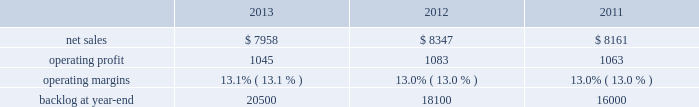Frequency ( aehf ) system , orion , global positioning satellite ( gps ) iii system , geostationary operational environmental satellite r-series ( goes-r ) , and mobile user objective system ( muos ) .
Operating profit for our space systems business segment includes our share of earnings for our investment in united launch alliance ( ula ) , which provides expendable launch services to the u.s .
Government .
Space systems 2019 operating results included the following ( in millions ) : .
2013 compared to 2012 space systems 2019 net sales for 2013 decreased $ 389 million , or 5% ( 5 % ) , compared to 2012 .
The decrease was primarily attributable to lower net sales of approximately $ 305 million for commercial satellite programs due to fewer deliveries ( zero delivered during 2013 compared to two for 2012 ) ; and about $ 290 million for the orion program due to lower volume .
The decreases were partially offset by higher net sales of approximately $ 130 million for government satellite programs due to net increased volume ; and about $ 65 million for strategic and defensive missile programs ( primarily fbm ) due to increased volume and risk retirements .
The increase for government satellite programs was primarily attributable to higher volume on aehf and other programs , partially offset by lower volume on goes-r , muos , and sbirs programs .
Space systems 2019 operating profit for 2013 decreased $ 38 million , or 4% ( 4 % ) , compared to 2012 .
The decrease was primarily attributable to lower operating profit of approximately $ 50 million for the orion program due to lower volume and risk retirements and about $ 30 million for government satellite programs due to decreased risk retirements , which were partially offset by higher equity earnings from joint ventures of approximately $ 35 million .
The decrease in operating profit for government satellite programs was primarily attributable to lower risk retirements for muos , gps iii , and other programs , partially offset by higher risk retirements for the sbirs and aehf programs .
Operating profit for 2013 included about $ 15 million of charges , net of recoveries , related to the november 2013 restructuring plan .
Adjustments not related to volume , including net profit booking rate adjustments and other matters , were approximately $ 15 million lower for 2013 compared to 2012 .
2012 compared to 2011 space systems 2019 net sales for 2012 increased $ 186 million , or 2% ( 2 % ) , compared to 2011 .
The increase was attributable to higher net sales of approximately $ 150 million due to increased commercial satellite deliveries ( two commercial satellites delivered in 2012 compared to one during 2011 ) ; about $ 125 million from the orion program due to higher volume and an increase in risk retirements ; and approximately $ 70 million from increased volume on various strategic and defensive missile programs .
Partially offsetting the increases were lower net sales of approximately $ 105 million from certain government satellite programs ( primarily sbirs and muos ) as a result of decreased volume and a decline in risk retirements ; and about $ 55 million from the nasa external tank program , which ended in connection with the completion of the space shuttle program in 2011 .
Space systems 2019 operating profit for 2012 increased $ 20 million , or 2% ( 2 % ) , compared to 2011 .
The increase was attributable to higher operating profit of approximately $ 60 million from commercial satellite programs due to increased deliveries and reserves recorded in 2011 ; and about $ 40 million from the orion program due to higher risk retirements and increased volume .
Partially offsetting the increases was lower operating profit of approximately $ 45 million from lower volume and risk retirements on certain government satellite programs ( primarily sbirs ) ; about $ 20 million from lower risk retirements and lower volume on the nasa external tank program , which ended in connection with the completion of the space shuttle program in 2011 ; and approximately $ 20 million from lower equity earnings as a decline in launch related activities at ula partially was offset by the resolution of contract cost matters associated with the wind-down of united space alliance ( usa ) .
Adjustments not related to volume , including net profit booking rate adjustments described above , were approximately $ 15 million higher for 2012 compared to 2011 .
Equity earnings total equity earnings recognized by space systems ( primarily ula in 2013 ) represented approximately $ 300 million , or 29% ( 29 % ) of this segment 2019s operating profit during 2013 .
During 2012 and 2011 , total equity earnings recognized by space systems from ula , usa , and the u.k .
Atomic weapons establishment joint venture represented approximately $ 265 million and $ 285 million , or 24% ( 24 % ) and 27% ( 27 % ) of this segment 2019s operating profit. .
What were average operating profit for space systems from 2011 to 2013 in millions? 
Computations: table_average(operating profit, none)
Answer: 1063.66667. Frequency ( aehf ) system , orion , global positioning satellite ( gps ) iii system , geostationary operational environmental satellite r-series ( goes-r ) , and mobile user objective system ( muos ) .
Operating profit for our space systems business segment includes our share of earnings for our investment in united launch alliance ( ula ) , which provides expendable launch services to the u.s .
Government .
Space systems 2019 operating results included the following ( in millions ) : .
2013 compared to 2012 space systems 2019 net sales for 2013 decreased $ 389 million , or 5% ( 5 % ) , compared to 2012 .
The decrease was primarily attributable to lower net sales of approximately $ 305 million for commercial satellite programs due to fewer deliveries ( zero delivered during 2013 compared to two for 2012 ) ; and about $ 290 million for the orion program due to lower volume .
The decreases were partially offset by higher net sales of approximately $ 130 million for government satellite programs due to net increased volume ; and about $ 65 million for strategic and defensive missile programs ( primarily fbm ) due to increased volume and risk retirements .
The increase for government satellite programs was primarily attributable to higher volume on aehf and other programs , partially offset by lower volume on goes-r , muos , and sbirs programs .
Space systems 2019 operating profit for 2013 decreased $ 38 million , or 4% ( 4 % ) , compared to 2012 .
The decrease was primarily attributable to lower operating profit of approximately $ 50 million for the orion program due to lower volume and risk retirements and about $ 30 million for government satellite programs due to decreased risk retirements , which were partially offset by higher equity earnings from joint ventures of approximately $ 35 million .
The decrease in operating profit for government satellite programs was primarily attributable to lower risk retirements for muos , gps iii , and other programs , partially offset by higher risk retirements for the sbirs and aehf programs .
Operating profit for 2013 included about $ 15 million of charges , net of recoveries , related to the november 2013 restructuring plan .
Adjustments not related to volume , including net profit booking rate adjustments and other matters , were approximately $ 15 million lower for 2013 compared to 2012 .
2012 compared to 2011 space systems 2019 net sales for 2012 increased $ 186 million , or 2% ( 2 % ) , compared to 2011 .
The increase was attributable to higher net sales of approximately $ 150 million due to increased commercial satellite deliveries ( two commercial satellites delivered in 2012 compared to one during 2011 ) ; about $ 125 million from the orion program due to higher volume and an increase in risk retirements ; and approximately $ 70 million from increased volume on various strategic and defensive missile programs .
Partially offsetting the increases were lower net sales of approximately $ 105 million from certain government satellite programs ( primarily sbirs and muos ) as a result of decreased volume and a decline in risk retirements ; and about $ 55 million from the nasa external tank program , which ended in connection with the completion of the space shuttle program in 2011 .
Space systems 2019 operating profit for 2012 increased $ 20 million , or 2% ( 2 % ) , compared to 2011 .
The increase was attributable to higher operating profit of approximately $ 60 million from commercial satellite programs due to increased deliveries and reserves recorded in 2011 ; and about $ 40 million from the orion program due to higher risk retirements and increased volume .
Partially offsetting the increases was lower operating profit of approximately $ 45 million from lower volume and risk retirements on certain government satellite programs ( primarily sbirs ) ; about $ 20 million from lower risk retirements and lower volume on the nasa external tank program , which ended in connection with the completion of the space shuttle program in 2011 ; and approximately $ 20 million from lower equity earnings as a decline in launch related activities at ula partially was offset by the resolution of contract cost matters associated with the wind-down of united space alliance ( usa ) .
Adjustments not related to volume , including net profit booking rate adjustments described above , were approximately $ 15 million higher for 2012 compared to 2011 .
Equity earnings total equity earnings recognized by space systems ( primarily ula in 2013 ) represented approximately $ 300 million , or 29% ( 29 % ) of this segment 2019s operating profit during 2013 .
During 2012 and 2011 , total equity earnings recognized by space systems from ula , usa , and the u.k .
Atomic weapons establishment joint venture represented approximately $ 265 million and $ 285 million , or 24% ( 24 % ) and 27% ( 27 % ) of this segment 2019s operating profit. .
What was the average net sales from 2011 to 2013? 
Computations: ((((7958 + 8347) + 8161) + 3) / 2)
Answer: 12234.5. 